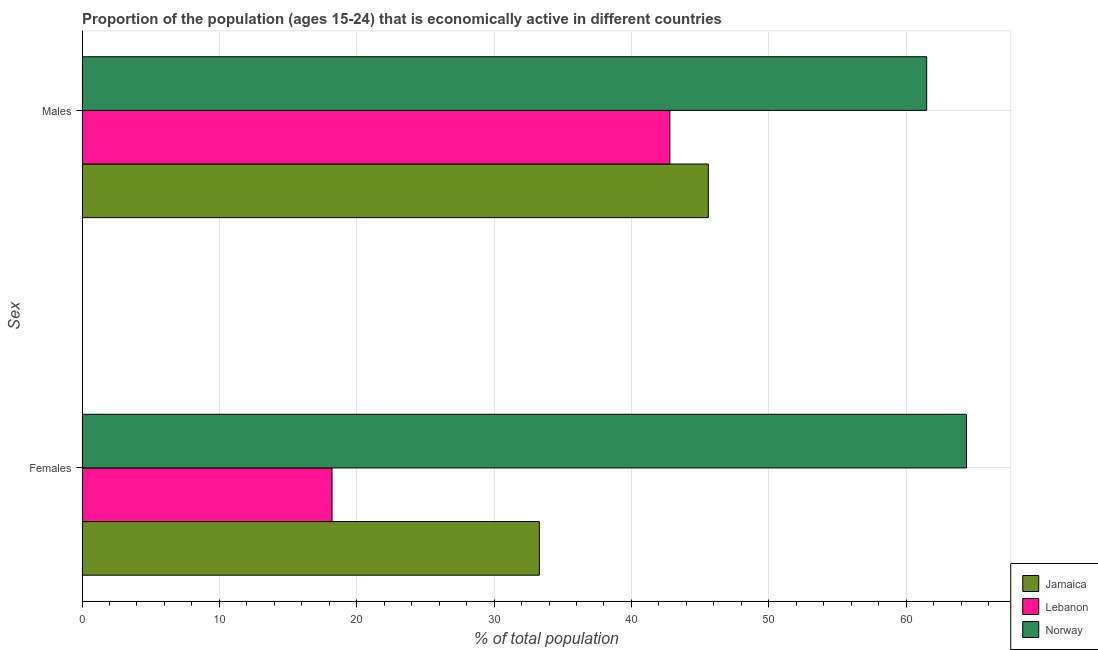How many different coloured bars are there?
Provide a short and direct response. 3. How many groups of bars are there?
Give a very brief answer. 2. Are the number of bars per tick equal to the number of legend labels?
Provide a short and direct response. Yes. Are the number of bars on each tick of the Y-axis equal?
Ensure brevity in your answer.  Yes. How many bars are there on the 2nd tick from the top?
Provide a succinct answer. 3. How many bars are there on the 1st tick from the bottom?
Ensure brevity in your answer.  3. What is the label of the 1st group of bars from the top?
Keep it short and to the point. Males. What is the percentage of economically active male population in Norway?
Your response must be concise. 61.5. Across all countries, what is the maximum percentage of economically active female population?
Provide a short and direct response. 64.4. Across all countries, what is the minimum percentage of economically active female population?
Ensure brevity in your answer.  18.2. In which country was the percentage of economically active female population maximum?
Your response must be concise. Norway. In which country was the percentage of economically active female population minimum?
Ensure brevity in your answer.  Lebanon. What is the total percentage of economically active male population in the graph?
Offer a terse response. 149.9. What is the difference between the percentage of economically active female population in Norway and that in Lebanon?
Keep it short and to the point. 46.2. What is the difference between the percentage of economically active female population in Jamaica and the percentage of economically active male population in Lebanon?
Give a very brief answer. -9.5. What is the average percentage of economically active male population per country?
Your response must be concise. 49.97. What is the difference between the percentage of economically active female population and percentage of economically active male population in Jamaica?
Offer a terse response. -12.3. In how many countries, is the percentage of economically active male population greater than 42 %?
Keep it short and to the point. 3. What is the ratio of the percentage of economically active male population in Jamaica to that in Lebanon?
Offer a very short reply. 1.07. In how many countries, is the percentage of economically active male population greater than the average percentage of economically active male population taken over all countries?
Provide a succinct answer. 1. What does the 2nd bar from the top in Males represents?
Offer a terse response. Lebanon. What does the 2nd bar from the bottom in Males represents?
Offer a very short reply. Lebanon. How many countries are there in the graph?
Give a very brief answer. 3. What is the difference between two consecutive major ticks on the X-axis?
Offer a terse response. 10. Are the values on the major ticks of X-axis written in scientific E-notation?
Keep it short and to the point. No. Does the graph contain any zero values?
Your response must be concise. No. How are the legend labels stacked?
Offer a very short reply. Vertical. What is the title of the graph?
Your answer should be compact. Proportion of the population (ages 15-24) that is economically active in different countries. What is the label or title of the X-axis?
Offer a terse response. % of total population. What is the label or title of the Y-axis?
Your answer should be very brief. Sex. What is the % of total population in Jamaica in Females?
Give a very brief answer. 33.3. What is the % of total population in Lebanon in Females?
Your answer should be compact. 18.2. What is the % of total population in Norway in Females?
Your response must be concise. 64.4. What is the % of total population of Jamaica in Males?
Provide a short and direct response. 45.6. What is the % of total population of Lebanon in Males?
Give a very brief answer. 42.8. What is the % of total population of Norway in Males?
Your answer should be compact. 61.5. Across all Sex, what is the maximum % of total population of Jamaica?
Offer a very short reply. 45.6. Across all Sex, what is the maximum % of total population of Lebanon?
Make the answer very short. 42.8. Across all Sex, what is the maximum % of total population in Norway?
Offer a very short reply. 64.4. Across all Sex, what is the minimum % of total population of Jamaica?
Ensure brevity in your answer.  33.3. Across all Sex, what is the minimum % of total population of Lebanon?
Offer a terse response. 18.2. Across all Sex, what is the minimum % of total population in Norway?
Make the answer very short. 61.5. What is the total % of total population in Jamaica in the graph?
Offer a very short reply. 78.9. What is the total % of total population in Lebanon in the graph?
Your answer should be compact. 61. What is the total % of total population of Norway in the graph?
Offer a terse response. 125.9. What is the difference between the % of total population of Lebanon in Females and that in Males?
Your answer should be very brief. -24.6. What is the difference between the % of total population of Norway in Females and that in Males?
Provide a short and direct response. 2.9. What is the difference between the % of total population in Jamaica in Females and the % of total population in Norway in Males?
Your response must be concise. -28.2. What is the difference between the % of total population in Lebanon in Females and the % of total population in Norway in Males?
Your answer should be very brief. -43.3. What is the average % of total population of Jamaica per Sex?
Give a very brief answer. 39.45. What is the average % of total population in Lebanon per Sex?
Ensure brevity in your answer.  30.5. What is the average % of total population in Norway per Sex?
Your answer should be very brief. 62.95. What is the difference between the % of total population of Jamaica and % of total population of Lebanon in Females?
Offer a very short reply. 15.1. What is the difference between the % of total population in Jamaica and % of total population in Norway in Females?
Your response must be concise. -31.1. What is the difference between the % of total population of Lebanon and % of total population of Norway in Females?
Keep it short and to the point. -46.2. What is the difference between the % of total population in Jamaica and % of total population in Lebanon in Males?
Make the answer very short. 2.8. What is the difference between the % of total population of Jamaica and % of total population of Norway in Males?
Offer a terse response. -15.9. What is the difference between the % of total population in Lebanon and % of total population in Norway in Males?
Make the answer very short. -18.7. What is the ratio of the % of total population of Jamaica in Females to that in Males?
Your response must be concise. 0.73. What is the ratio of the % of total population of Lebanon in Females to that in Males?
Keep it short and to the point. 0.43. What is the ratio of the % of total population in Norway in Females to that in Males?
Ensure brevity in your answer.  1.05. What is the difference between the highest and the second highest % of total population of Lebanon?
Give a very brief answer. 24.6. What is the difference between the highest and the second highest % of total population in Norway?
Give a very brief answer. 2.9. What is the difference between the highest and the lowest % of total population of Lebanon?
Your answer should be very brief. 24.6. What is the difference between the highest and the lowest % of total population in Norway?
Provide a short and direct response. 2.9. 